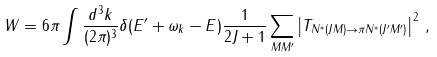Convert formula to latex. <formula><loc_0><loc_0><loc_500><loc_500>W & = 6 \pi \int \frac { d ^ { 3 } k } { ( 2 \pi ) ^ { 3 } } \delta ( E ^ { \prime } + \omega _ { k } - E ) \frac { 1 } { 2 J + 1 } \sum _ { M M ^ { \prime } } \left | T _ { N ^ { * } ( J M ) \to \pi N ^ { * } ( J ^ { \prime } M ^ { \prime } ) } \right | ^ { 2 } \, ,</formula> 